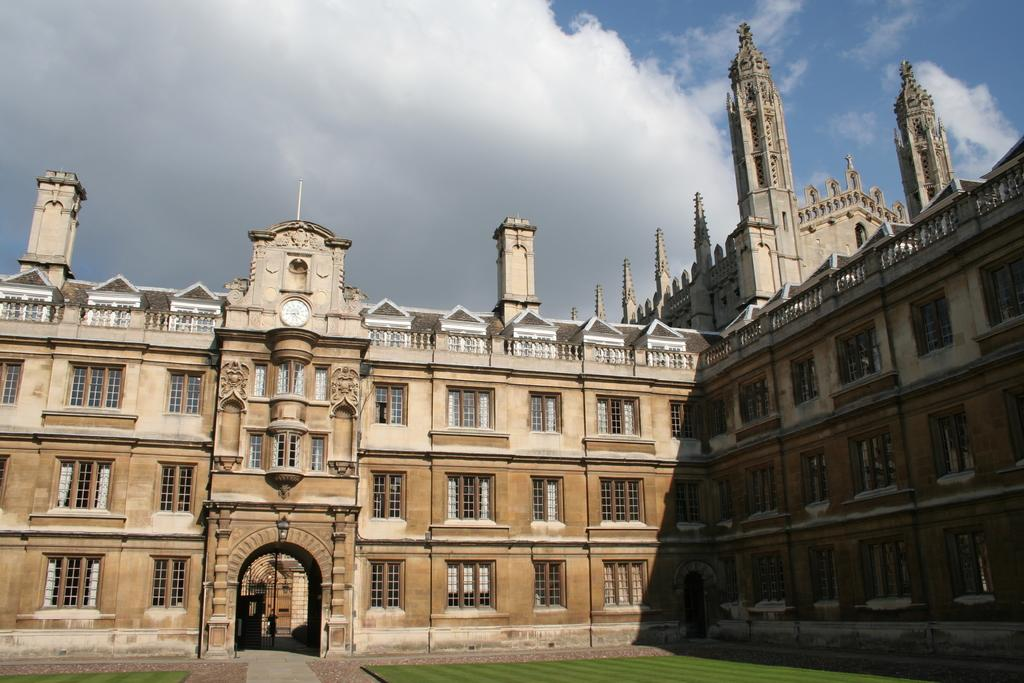What type of structures can be seen in the image? There are buildings in the image. What type of vegetation is at the bottom of the image? There is grass at the bottom of the image. What is visible at the top of the image? The sky is visible at the top of the image. How would you describe the sky in the image? The sky appears to be cloudy. What type of art is the secretary using to unlock the door in the image? There is no art or secretary present in the image, and no door is visible to be unlocked. 